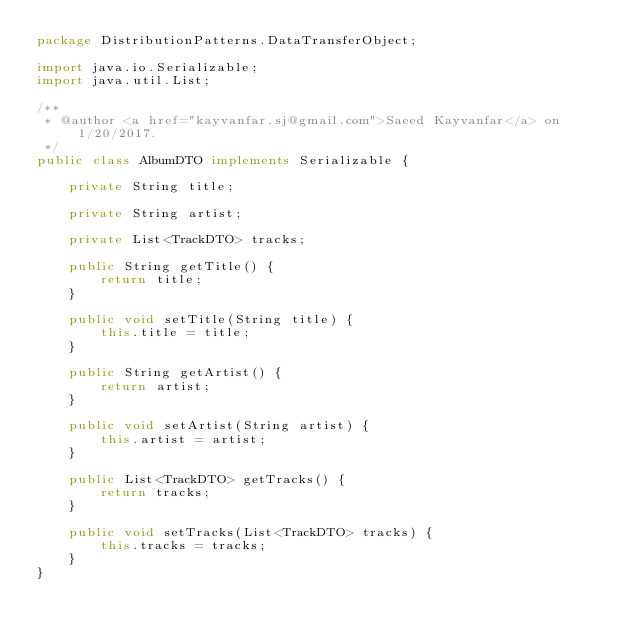<code> <loc_0><loc_0><loc_500><loc_500><_Java_>package DistributionPatterns.DataTransferObject;

import java.io.Serializable;
import java.util.List;

/**
 * @author <a href="kayvanfar.sj@gmail.com">Saeed Kayvanfar</a> on 1/20/2017.
 */
public class AlbumDTO implements Serializable {

    private String title;

    private String artist;

    private List<TrackDTO> tracks;

    public String getTitle() {
        return title;
    }

    public void setTitle(String title) {
        this.title = title;
    }

    public String getArtist() {
        return artist;
    }

    public void setArtist(String artist) {
        this.artist = artist;
    }

    public List<TrackDTO> getTracks() {
        return tracks;
    }

    public void setTracks(List<TrackDTO> tracks) {
        this.tracks = tracks;
    }
}
</code> 